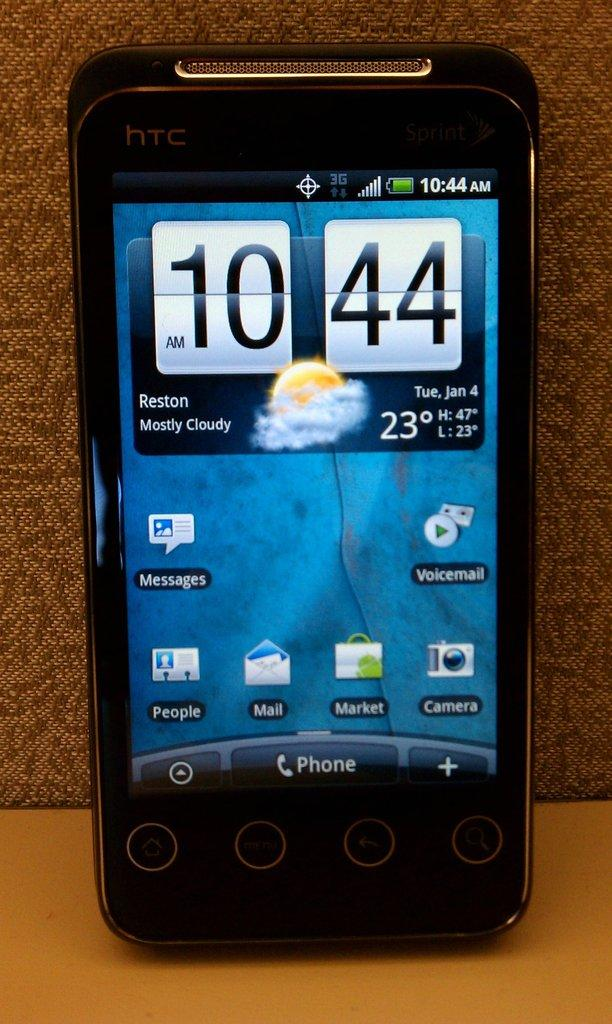<image>
Give a short and clear explanation of the subsequent image. The time shown on this htc mobiel is 10:44 am. 